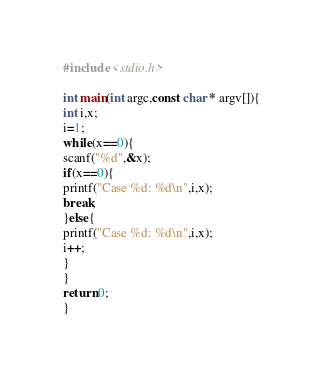Convert code to text. <code><loc_0><loc_0><loc_500><loc_500><_C_>#include <stdio.h>
 
int main(int argc,const char * argv[]){
int i,x;
i=1;
while(x==0){
scanf("%d",&x);
if(x==0){
printf("Case %d: %d\n",i,x);
break;
}else{
printf("Case %d: %d\n",i,x);
i++;
}
}
return 0;
}</code> 